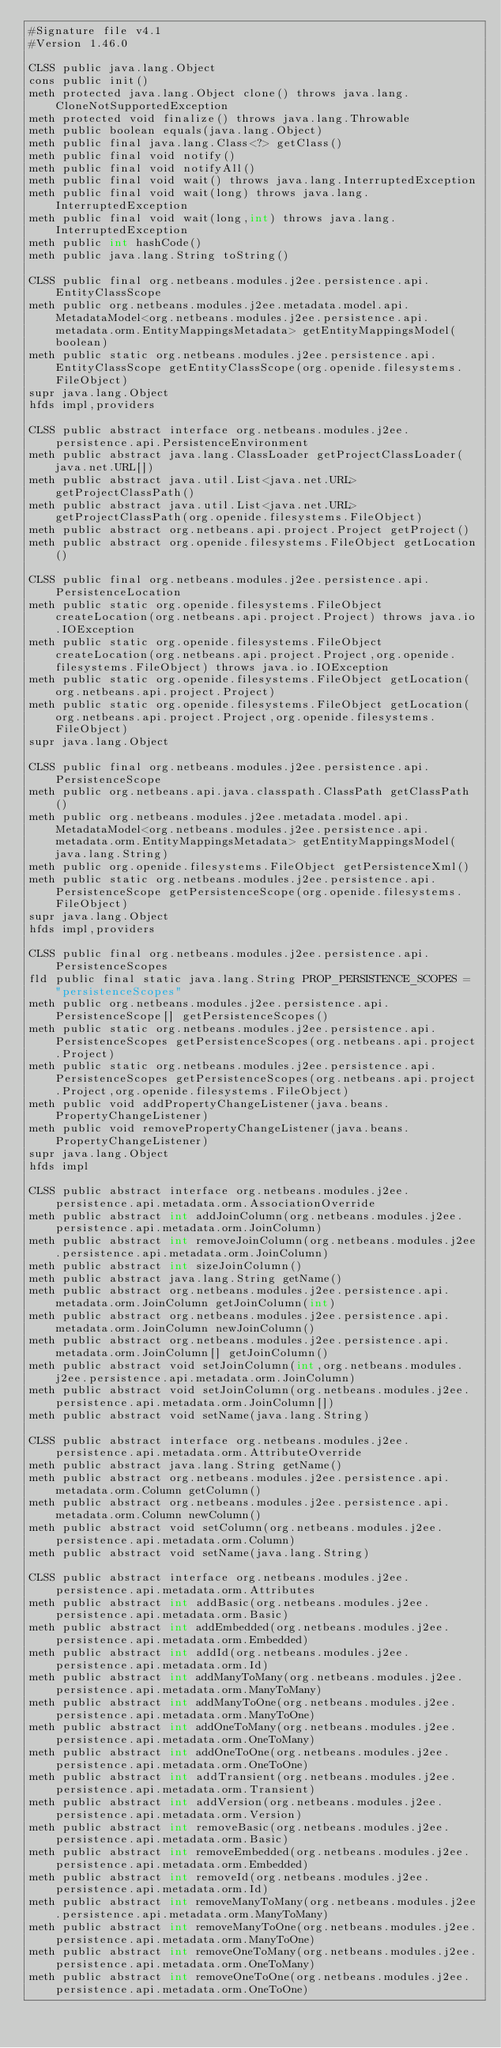<code> <loc_0><loc_0><loc_500><loc_500><_SML_>#Signature file v4.1
#Version 1.46.0

CLSS public java.lang.Object
cons public init()
meth protected java.lang.Object clone() throws java.lang.CloneNotSupportedException
meth protected void finalize() throws java.lang.Throwable
meth public boolean equals(java.lang.Object)
meth public final java.lang.Class<?> getClass()
meth public final void notify()
meth public final void notifyAll()
meth public final void wait() throws java.lang.InterruptedException
meth public final void wait(long) throws java.lang.InterruptedException
meth public final void wait(long,int) throws java.lang.InterruptedException
meth public int hashCode()
meth public java.lang.String toString()

CLSS public final org.netbeans.modules.j2ee.persistence.api.EntityClassScope
meth public org.netbeans.modules.j2ee.metadata.model.api.MetadataModel<org.netbeans.modules.j2ee.persistence.api.metadata.orm.EntityMappingsMetadata> getEntityMappingsModel(boolean)
meth public static org.netbeans.modules.j2ee.persistence.api.EntityClassScope getEntityClassScope(org.openide.filesystems.FileObject)
supr java.lang.Object
hfds impl,providers

CLSS public abstract interface org.netbeans.modules.j2ee.persistence.api.PersistenceEnvironment
meth public abstract java.lang.ClassLoader getProjectClassLoader(java.net.URL[])
meth public abstract java.util.List<java.net.URL> getProjectClassPath()
meth public abstract java.util.List<java.net.URL> getProjectClassPath(org.openide.filesystems.FileObject)
meth public abstract org.netbeans.api.project.Project getProject()
meth public abstract org.openide.filesystems.FileObject getLocation()

CLSS public final org.netbeans.modules.j2ee.persistence.api.PersistenceLocation
meth public static org.openide.filesystems.FileObject createLocation(org.netbeans.api.project.Project) throws java.io.IOException
meth public static org.openide.filesystems.FileObject createLocation(org.netbeans.api.project.Project,org.openide.filesystems.FileObject) throws java.io.IOException
meth public static org.openide.filesystems.FileObject getLocation(org.netbeans.api.project.Project)
meth public static org.openide.filesystems.FileObject getLocation(org.netbeans.api.project.Project,org.openide.filesystems.FileObject)
supr java.lang.Object

CLSS public final org.netbeans.modules.j2ee.persistence.api.PersistenceScope
meth public org.netbeans.api.java.classpath.ClassPath getClassPath()
meth public org.netbeans.modules.j2ee.metadata.model.api.MetadataModel<org.netbeans.modules.j2ee.persistence.api.metadata.orm.EntityMappingsMetadata> getEntityMappingsModel(java.lang.String)
meth public org.openide.filesystems.FileObject getPersistenceXml()
meth public static org.netbeans.modules.j2ee.persistence.api.PersistenceScope getPersistenceScope(org.openide.filesystems.FileObject)
supr java.lang.Object
hfds impl,providers

CLSS public final org.netbeans.modules.j2ee.persistence.api.PersistenceScopes
fld public final static java.lang.String PROP_PERSISTENCE_SCOPES = "persistenceScopes"
meth public org.netbeans.modules.j2ee.persistence.api.PersistenceScope[] getPersistenceScopes()
meth public static org.netbeans.modules.j2ee.persistence.api.PersistenceScopes getPersistenceScopes(org.netbeans.api.project.Project)
meth public static org.netbeans.modules.j2ee.persistence.api.PersistenceScopes getPersistenceScopes(org.netbeans.api.project.Project,org.openide.filesystems.FileObject)
meth public void addPropertyChangeListener(java.beans.PropertyChangeListener)
meth public void removePropertyChangeListener(java.beans.PropertyChangeListener)
supr java.lang.Object
hfds impl

CLSS public abstract interface org.netbeans.modules.j2ee.persistence.api.metadata.orm.AssociationOverride
meth public abstract int addJoinColumn(org.netbeans.modules.j2ee.persistence.api.metadata.orm.JoinColumn)
meth public abstract int removeJoinColumn(org.netbeans.modules.j2ee.persistence.api.metadata.orm.JoinColumn)
meth public abstract int sizeJoinColumn()
meth public abstract java.lang.String getName()
meth public abstract org.netbeans.modules.j2ee.persistence.api.metadata.orm.JoinColumn getJoinColumn(int)
meth public abstract org.netbeans.modules.j2ee.persistence.api.metadata.orm.JoinColumn newJoinColumn()
meth public abstract org.netbeans.modules.j2ee.persistence.api.metadata.orm.JoinColumn[] getJoinColumn()
meth public abstract void setJoinColumn(int,org.netbeans.modules.j2ee.persistence.api.metadata.orm.JoinColumn)
meth public abstract void setJoinColumn(org.netbeans.modules.j2ee.persistence.api.metadata.orm.JoinColumn[])
meth public abstract void setName(java.lang.String)

CLSS public abstract interface org.netbeans.modules.j2ee.persistence.api.metadata.orm.AttributeOverride
meth public abstract java.lang.String getName()
meth public abstract org.netbeans.modules.j2ee.persistence.api.metadata.orm.Column getColumn()
meth public abstract org.netbeans.modules.j2ee.persistence.api.metadata.orm.Column newColumn()
meth public abstract void setColumn(org.netbeans.modules.j2ee.persistence.api.metadata.orm.Column)
meth public abstract void setName(java.lang.String)

CLSS public abstract interface org.netbeans.modules.j2ee.persistence.api.metadata.orm.Attributes
meth public abstract int addBasic(org.netbeans.modules.j2ee.persistence.api.metadata.orm.Basic)
meth public abstract int addEmbedded(org.netbeans.modules.j2ee.persistence.api.metadata.orm.Embedded)
meth public abstract int addId(org.netbeans.modules.j2ee.persistence.api.metadata.orm.Id)
meth public abstract int addManyToMany(org.netbeans.modules.j2ee.persistence.api.metadata.orm.ManyToMany)
meth public abstract int addManyToOne(org.netbeans.modules.j2ee.persistence.api.metadata.orm.ManyToOne)
meth public abstract int addOneToMany(org.netbeans.modules.j2ee.persistence.api.metadata.orm.OneToMany)
meth public abstract int addOneToOne(org.netbeans.modules.j2ee.persistence.api.metadata.orm.OneToOne)
meth public abstract int addTransient(org.netbeans.modules.j2ee.persistence.api.metadata.orm.Transient)
meth public abstract int addVersion(org.netbeans.modules.j2ee.persistence.api.metadata.orm.Version)
meth public abstract int removeBasic(org.netbeans.modules.j2ee.persistence.api.metadata.orm.Basic)
meth public abstract int removeEmbedded(org.netbeans.modules.j2ee.persistence.api.metadata.orm.Embedded)
meth public abstract int removeId(org.netbeans.modules.j2ee.persistence.api.metadata.orm.Id)
meth public abstract int removeManyToMany(org.netbeans.modules.j2ee.persistence.api.metadata.orm.ManyToMany)
meth public abstract int removeManyToOne(org.netbeans.modules.j2ee.persistence.api.metadata.orm.ManyToOne)
meth public abstract int removeOneToMany(org.netbeans.modules.j2ee.persistence.api.metadata.orm.OneToMany)
meth public abstract int removeOneToOne(org.netbeans.modules.j2ee.persistence.api.metadata.orm.OneToOne)</code> 